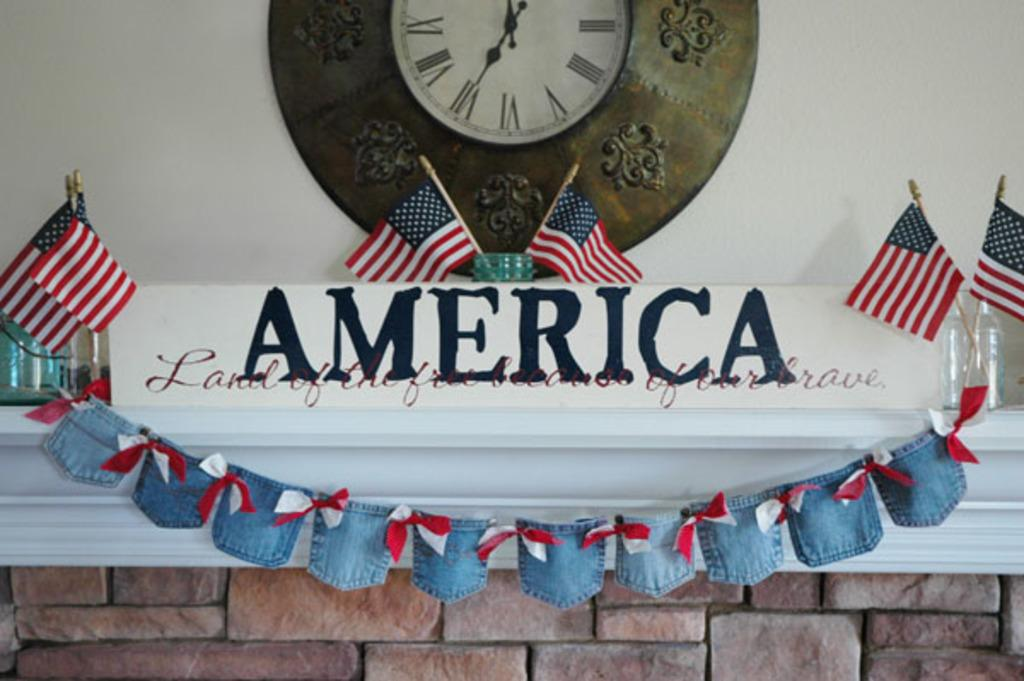<image>
Relay a brief, clear account of the picture shown. American Flags and a clock above the banner, which the banner says America, Land of the Free and of our brave. 